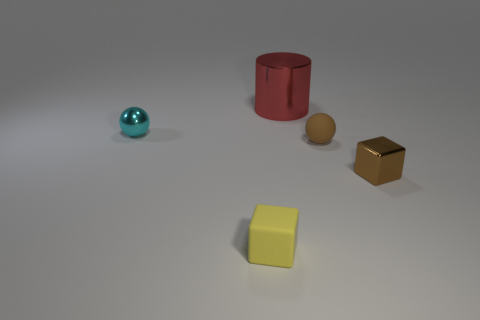What materials could these objects be made of, based on their appearance? The objects in the image appear to have different surface textures suggesting varied materials. The light blue sphere has a shiny, reflective surface, possibly made of polished metal or glass. The yellow cube looks matte, indicative of a plastic or painted wood material. The golden cube has a metallic sheen that implies it could be made of brass or gold-painted metal. The red cylinder's smoothness is consistent with a painted metal or plastic finish. Lastly, the brown sphere's slightly dulled texture may suggest a material like rubber or soft plastic. 